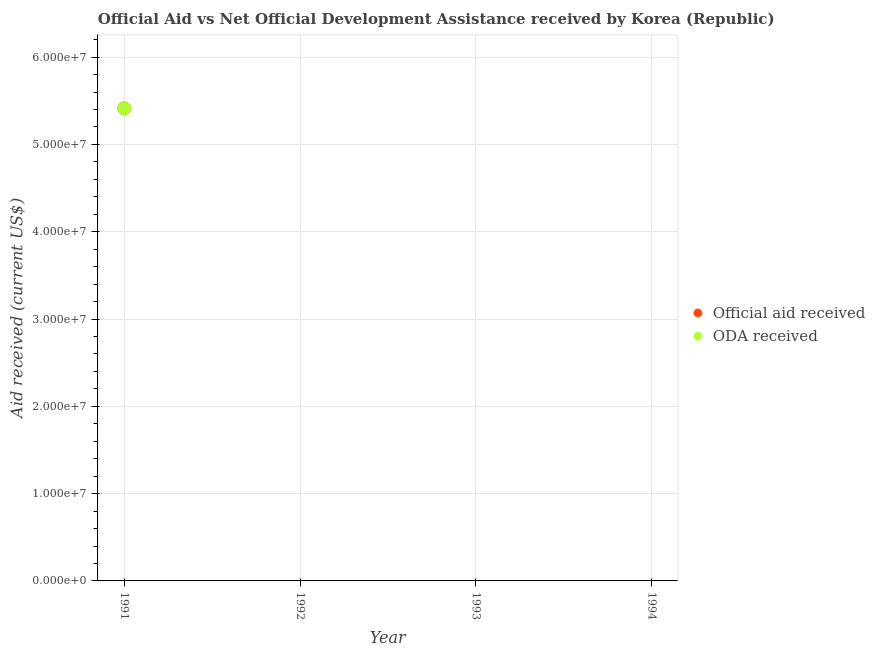Is the number of dotlines equal to the number of legend labels?
Offer a terse response. No. Across all years, what is the maximum oda received?
Give a very brief answer. 5.41e+07. What is the total oda received in the graph?
Make the answer very short. 5.41e+07. What is the difference between the official aid received in 1992 and the oda received in 1991?
Ensure brevity in your answer.  -5.41e+07. What is the average official aid received per year?
Provide a short and direct response. 1.35e+07. In the year 1991, what is the difference between the official aid received and oda received?
Your answer should be compact. 0. What is the difference between the highest and the lowest official aid received?
Your answer should be compact. 5.41e+07. In how many years, is the official aid received greater than the average official aid received taken over all years?
Ensure brevity in your answer.  1. Does the official aid received monotonically increase over the years?
Make the answer very short. No. How many dotlines are there?
Give a very brief answer. 2. What is the difference between two consecutive major ticks on the Y-axis?
Ensure brevity in your answer.  1.00e+07. Are the values on the major ticks of Y-axis written in scientific E-notation?
Ensure brevity in your answer.  Yes. Where does the legend appear in the graph?
Your response must be concise. Center right. How many legend labels are there?
Your response must be concise. 2. How are the legend labels stacked?
Give a very brief answer. Vertical. What is the title of the graph?
Offer a terse response. Official Aid vs Net Official Development Assistance received by Korea (Republic) . What is the label or title of the X-axis?
Offer a terse response. Year. What is the label or title of the Y-axis?
Give a very brief answer. Aid received (current US$). What is the Aid received (current US$) of Official aid received in 1991?
Your answer should be compact. 5.41e+07. What is the Aid received (current US$) in ODA received in 1991?
Provide a succinct answer. 5.41e+07. Across all years, what is the maximum Aid received (current US$) of Official aid received?
Provide a succinct answer. 5.41e+07. Across all years, what is the maximum Aid received (current US$) of ODA received?
Ensure brevity in your answer.  5.41e+07. What is the total Aid received (current US$) of Official aid received in the graph?
Offer a very short reply. 5.41e+07. What is the total Aid received (current US$) of ODA received in the graph?
Make the answer very short. 5.41e+07. What is the average Aid received (current US$) of Official aid received per year?
Give a very brief answer. 1.35e+07. What is the average Aid received (current US$) of ODA received per year?
Provide a succinct answer. 1.35e+07. In the year 1991, what is the difference between the Aid received (current US$) in Official aid received and Aid received (current US$) in ODA received?
Your answer should be very brief. 0. What is the difference between the highest and the lowest Aid received (current US$) in Official aid received?
Your response must be concise. 5.41e+07. What is the difference between the highest and the lowest Aid received (current US$) in ODA received?
Provide a short and direct response. 5.41e+07. 